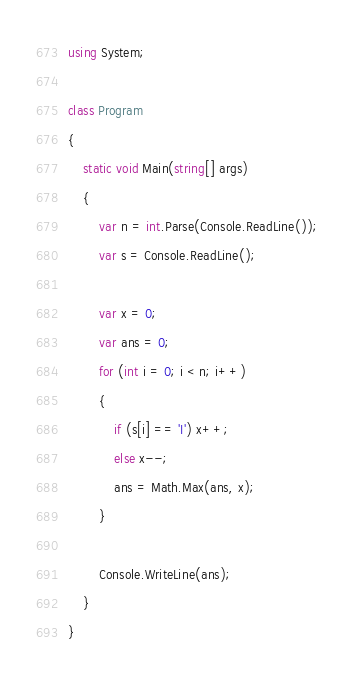<code> <loc_0><loc_0><loc_500><loc_500><_C#_>using System;

class Program
{
    static void Main(string[] args)
    {
        var n = int.Parse(Console.ReadLine());
        var s = Console.ReadLine();

        var x = 0;
        var ans = 0;
        for (int i = 0; i < n; i++)
        {
            if (s[i] == 'I') x++;
            else x--;
            ans = Math.Max(ans, x);
        }

        Console.WriteLine(ans);
    }
}
</code> 